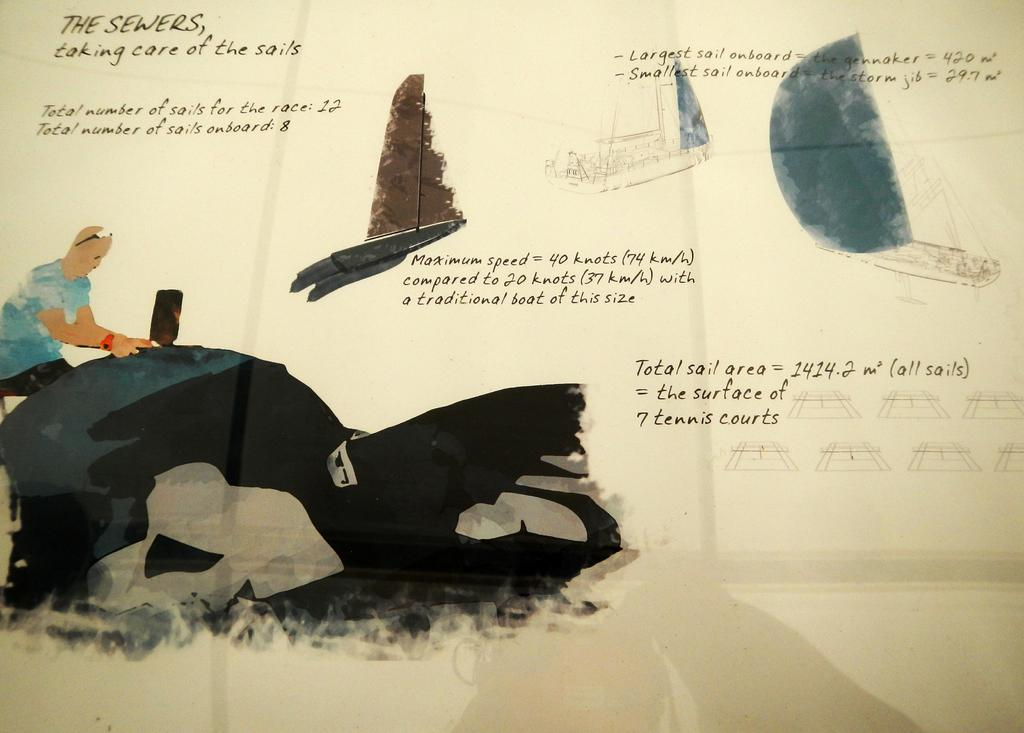What type of visual representation is shown in the image? The image is a poster. Who or what is depicted in the poster? There is a person in the poster. What else can be seen in the poster besides the person? There are boats in the poster. What type of cow is featured in the poster? There is no cow present in the poster; it features a person and boats. 